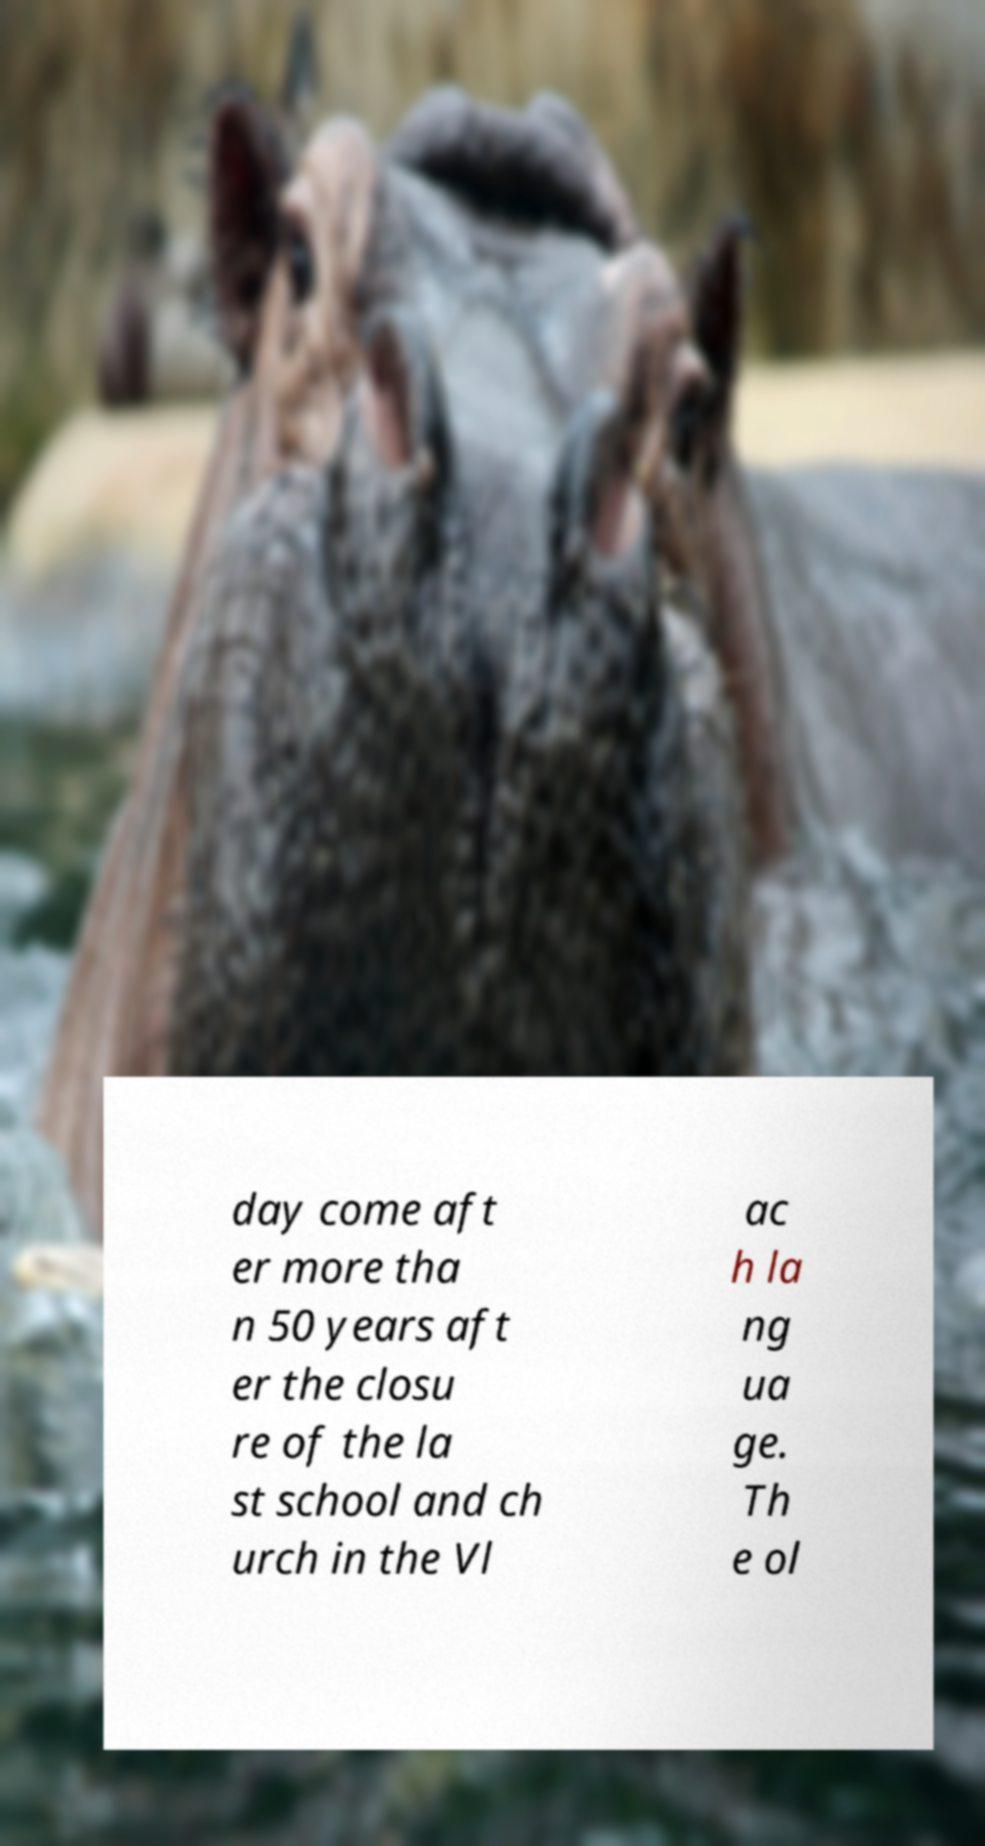For documentation purposes, I need the text within this image transcribed. Could you provide that? day come aft er more tha n 50 years aft er the closu re of the la st school and ch urch in the Vl ac h la ng ua ge. Th e ol 